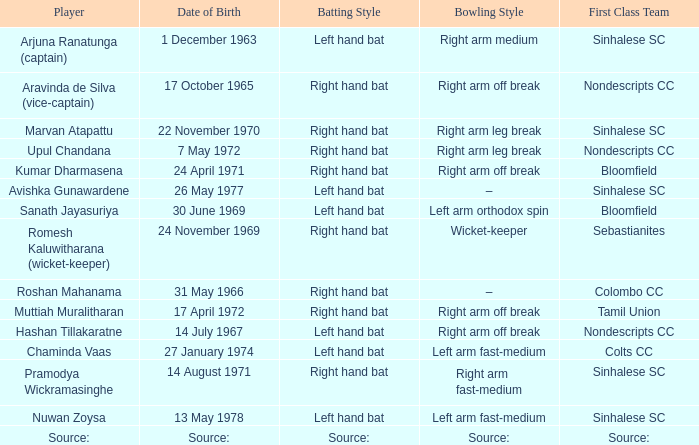When was roshan mahanama born? 31 May 1966. I'm looking to parse the entire table for insights. Could you assist me with that? {'header': ['Player', 'Date of Birth', 'Batting Style', 'Bowling Style', 'First Class Team'], 'rows': [['Arjuna Ranatunga (captain)', '1 December 1963', 'Left hand bat', 'Right arm medium', 'Sinhalese SC'], ['Aravinda de Silva (vice-captain)', '17 October 1965', 'Right hand bat', 'Right arm off break', 'Nondescripts CC'], ['Marvan Atapattu', '22 November 1970', 'Right hand bat', 'Right arm leg break', 'Sinhalese SC'], ['Upul Chandana', '7 May 1972', 'Right hand bat', 'Right arm leg break', 'Nondescripts CC'], ['Kumar Dharmasena', '24 April 1971', 'Right hand bat', 'Right arm off break', 'Bloomfield'], ['Avishka Gunawardene', '26 May 1977', 'Left hand bat', '–', 'Sinhalese SC'], ['Sanath Jayasuriya', '30 June 1969', 'Left hand bat', 'Left arm orthodox spin', 'Bloomfield'], ['Romesh Kaluwitharana (wicket-keeper)', '24 November 1969', 'Right hand bat', 'Wicket-keeper', 'Sebastianites'], ['Roshan Mahanama', '31 May 1966', 'Right hand bat', '–', 'Colombo CC'], ['Muttiah Muralitharan', '17 April 1972', 'Right hand bat', 'Right arm off break', 'Tamil Union'], ['Hashan Tillakaratne', '14 July 1967', 'Left hand bat', 'Right arm off break', 'Nondescripts CC'], ['Chaminda Vaas', '27 January 1974', 'Left hand bat', 'Left arm fast-medium', 'Colts CC'], ['Pramodya Wickramasinghe', '14 August 1971', 'Right hand bat', 'Right arm fast-medium', 'Sinhalese SC'], ['Nuwan Zoysa', '13 May 1978', 'Left hand bat', 'Left arm fast-medium', 'Sinhalese SC'], ['Source:', 'Source:', 'Source:', 'Source:', 'Source:']]} 